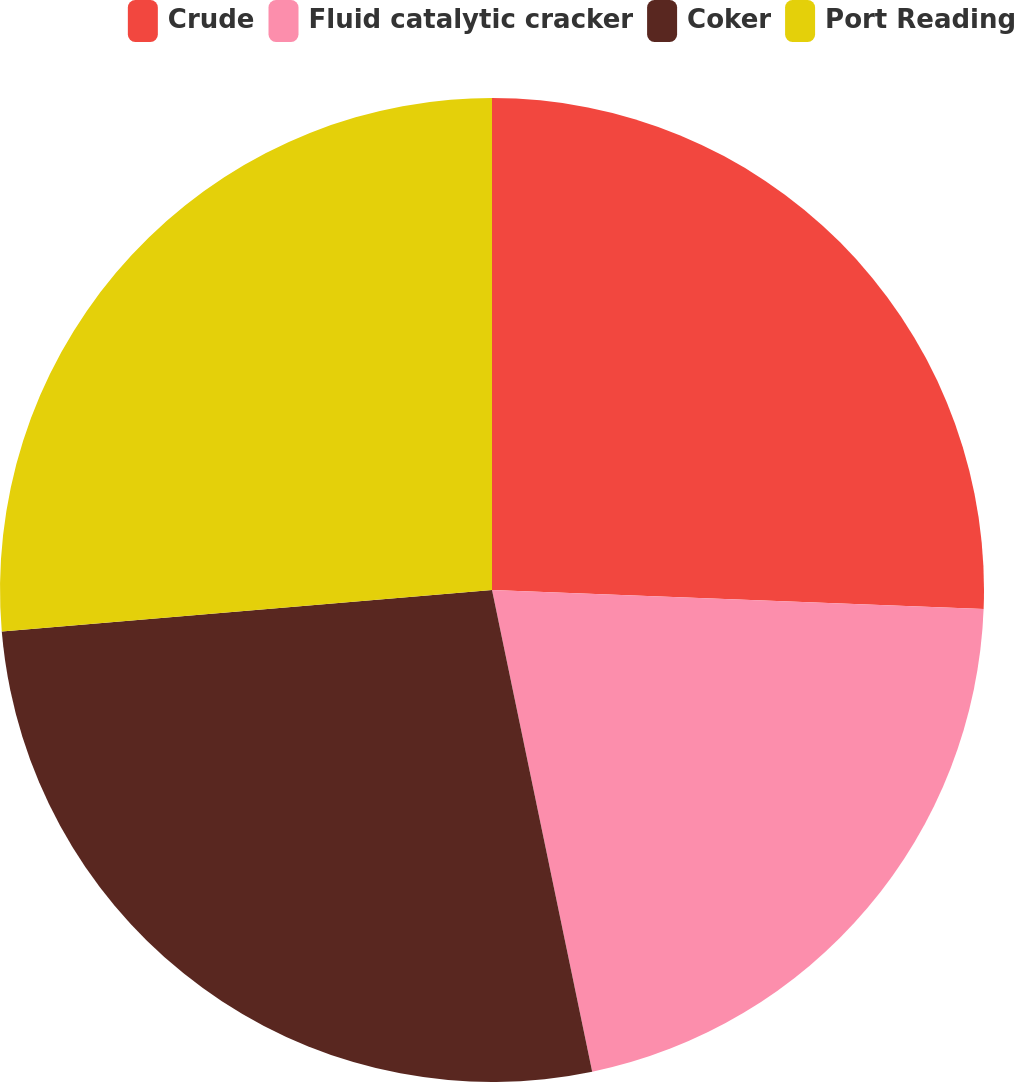<chart> <loc_0><loc_0><loc_500><loc_500><pie_chart><fcel>Crude<fcel>Fluid catalytic cracker<fcel>Coker<fcel>Port Reading<nl><fcel>25.62%<fcel>21.12%<fcel>26.92%<fcel>26.35%<nl></chart> 